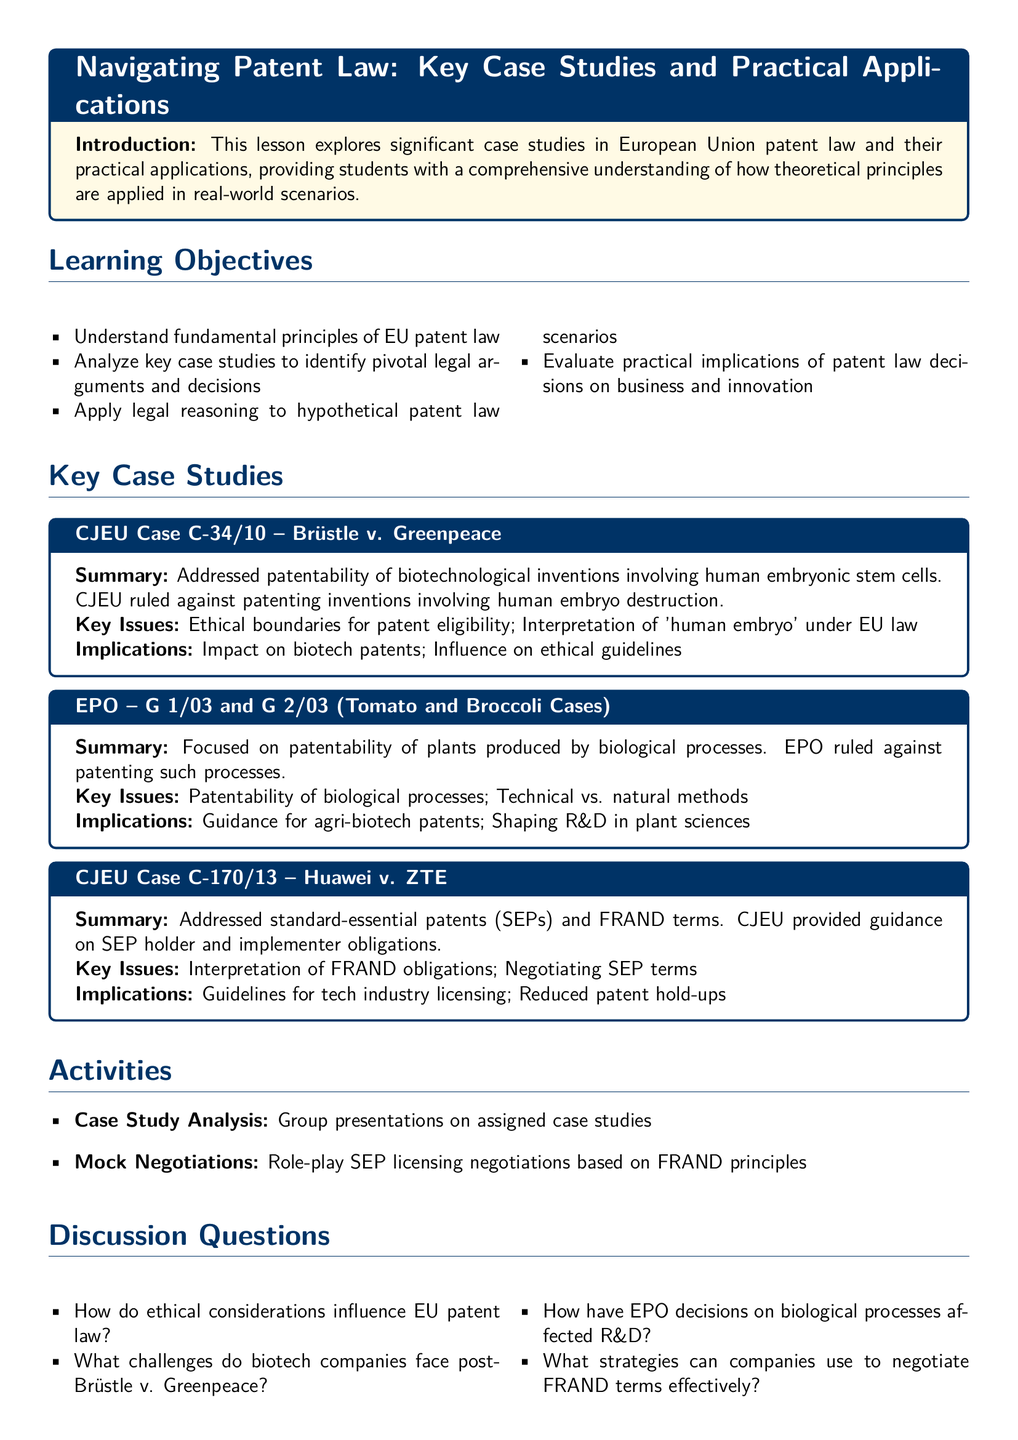What is the title of the lesson plan? The title of the lesson plan is given in the introduction box at the top of the document.
Answer: Navigating Patent Law: Key Case Studies and Practical Applications How many key case studies are presented? The number of key case studies can be counted in the Key Case Studies section.
Answer: Three What is the case number for Brüstle v. Greenpeace? The case number is noted in the section title for the specific case study.
Answer: C-34/10 What ethical issue is addressed in Brüstle v. Greenpeace? The ethical issue is detailed in the summary of the key case study.
Answer: Patentability of biotechnological inventions involving human embryonic stem cells What do the CJEU case and EPO decisions influence? This influence is mentioned in the implications section of the case studies.
Answer: Biotech patents and guidance for agri-biotech patents What activity involves role-play? The activity described requires practical application through role-play techniques.
Answer: Mock Negotiations Which book is listed as a resource in the lesson plan? The book title is noted in the Resources section for further reading.
Answer: European Patent Law: Law and Procedure under the EPC and PCT How does CJEU case C-170/13 relate to technology? The relationship is implied in the summary regarding the obligations of patent holders and implementers.
Answer: Guidelines for tech industry licensing 